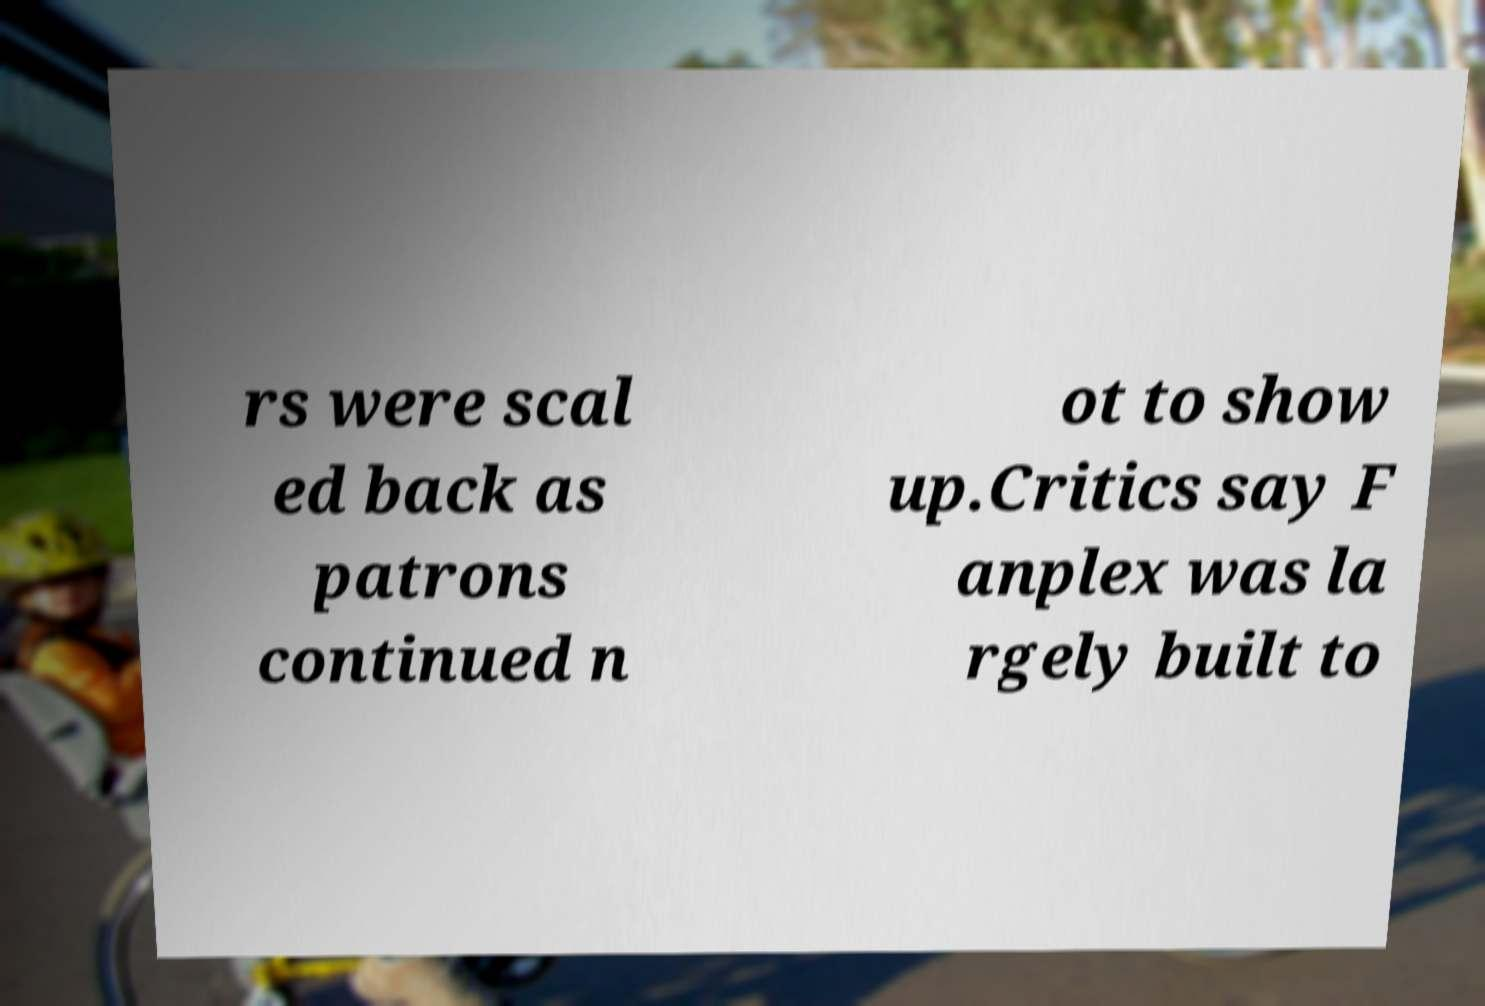What messages or text are displayed in this image? I need them in a readable, typed format. rs were scal ed back as patrons continued n ot to show up.Critics say F anplex was la rgely built to 